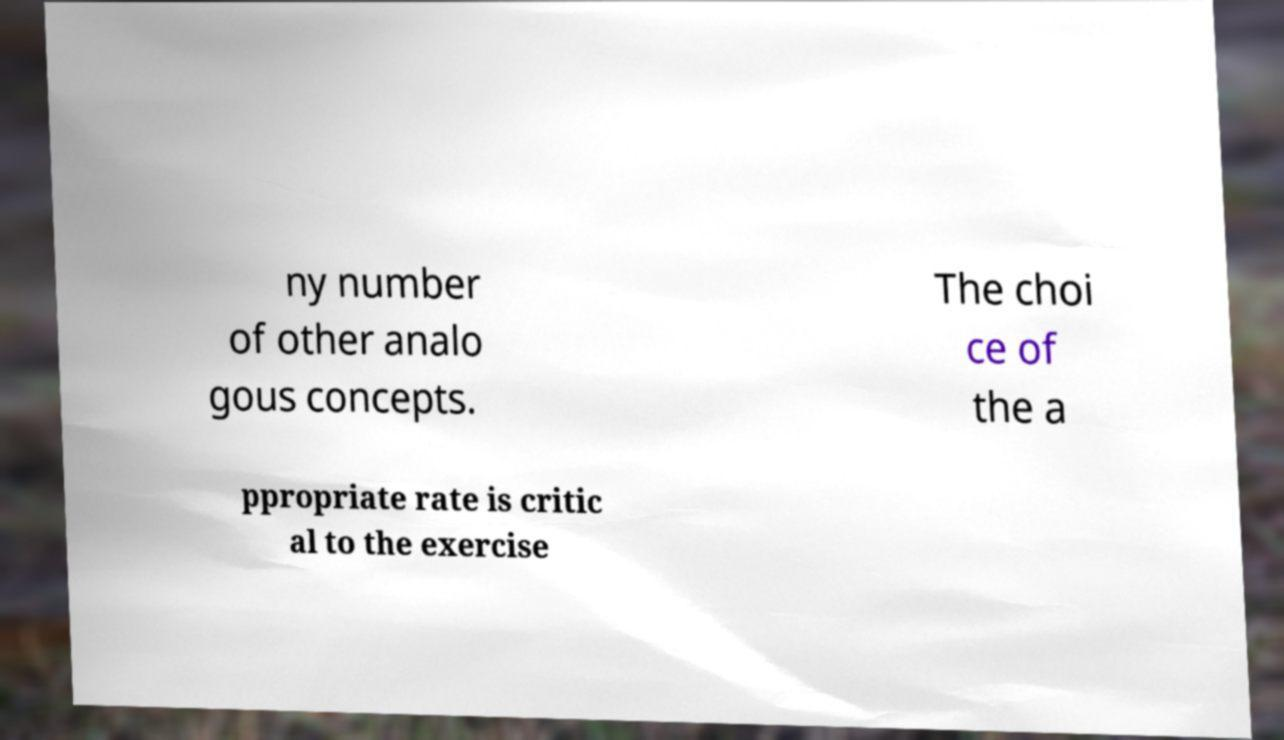Could you extract and type out the text from this image? ny number of other analo gous concepts. The choi ce of the a ppropriate rate is critic al to the exercise 